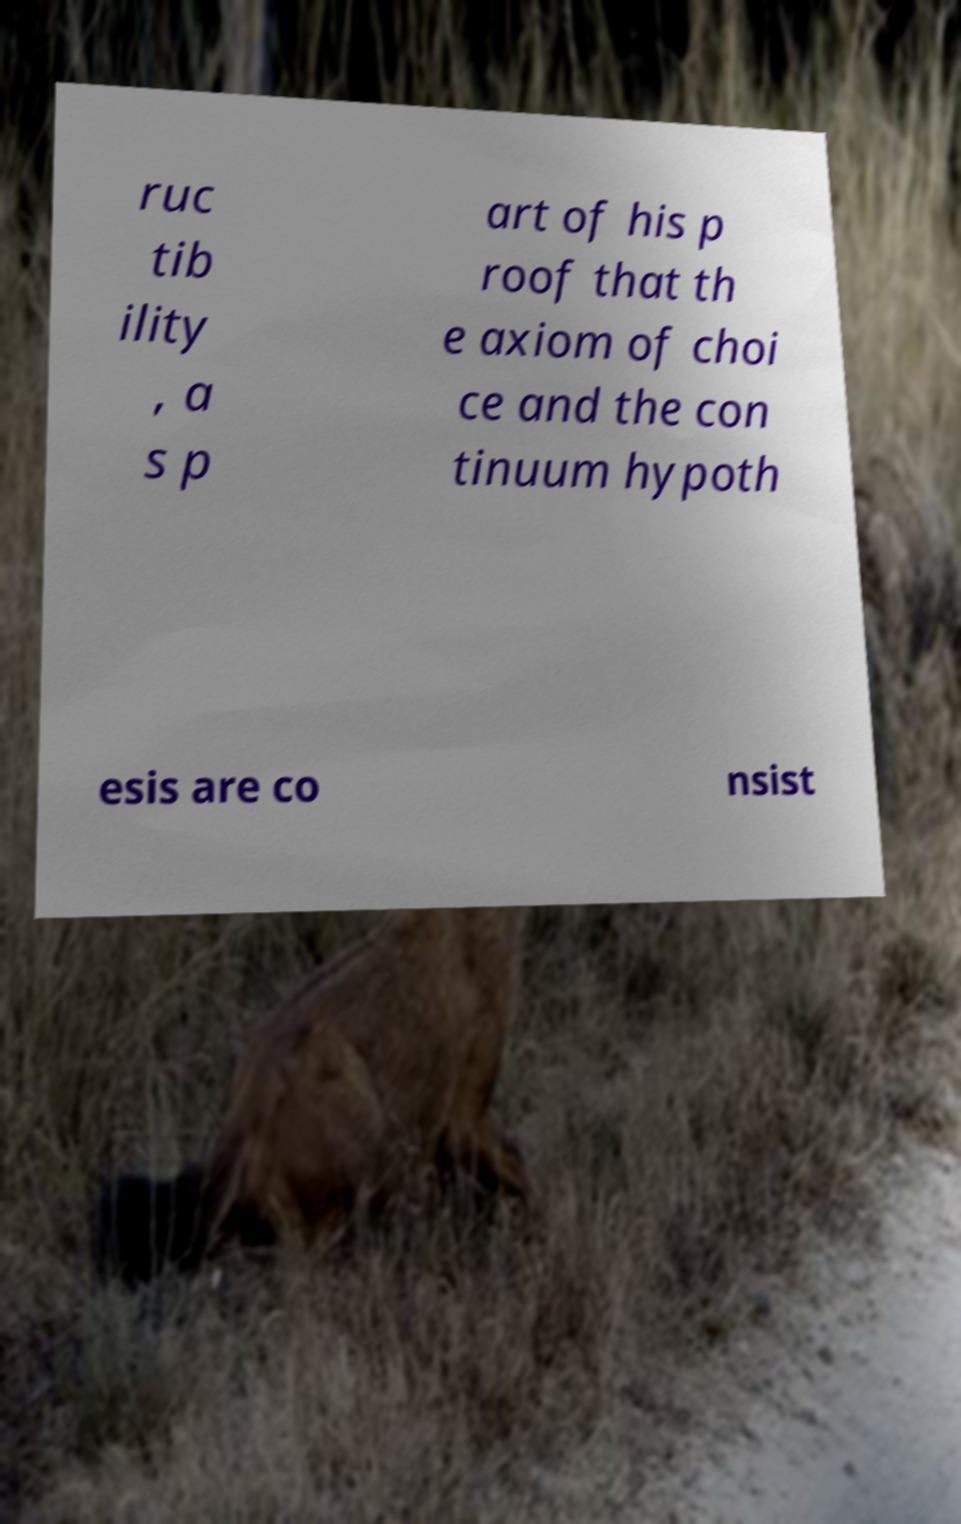There's text embedded in this image that I need extracted. Can you transcribe it verbatim? ruc tib ility , a s p art of his p roof that th e axiom of choi ce and the con tinuum hypoth esis are co nsist 